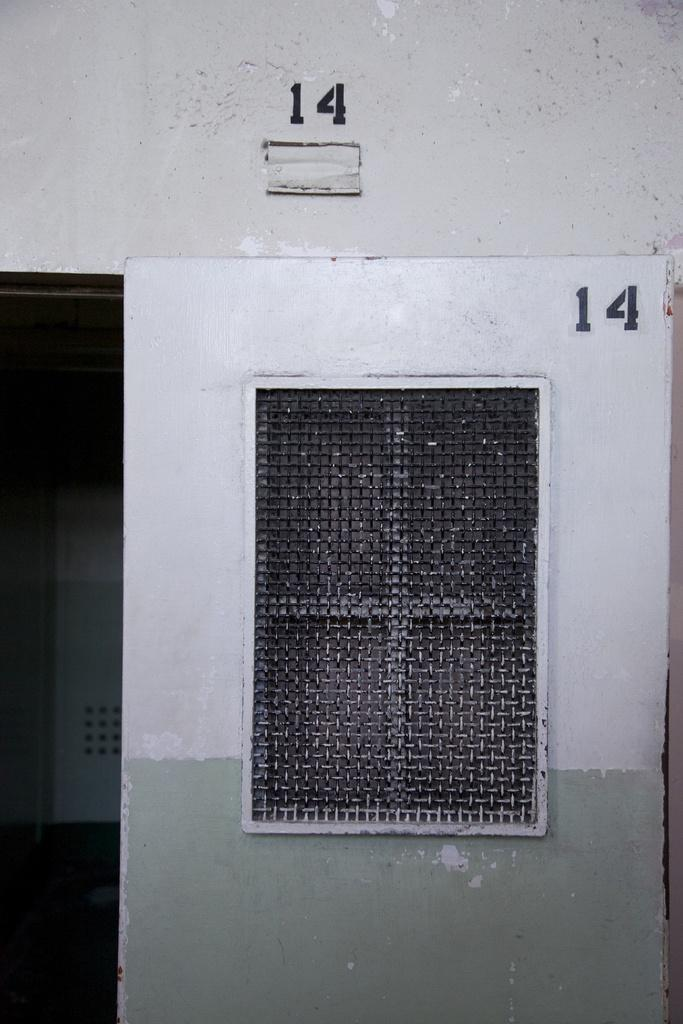What type of structure can be seen in the image? There is a wall in the image. Are there any openings in the wall? Yes, there is a window in the wall. What other object is visible in the image? There is a metal fence in the image. Can you describe any markings or numbers on the wall? There is a number at two places on the wall. Where is the vase placed in the image? There is no vase present in the image. What type of underwear can be seen hanging on the metal fence? There is no underwear visible in the image. 